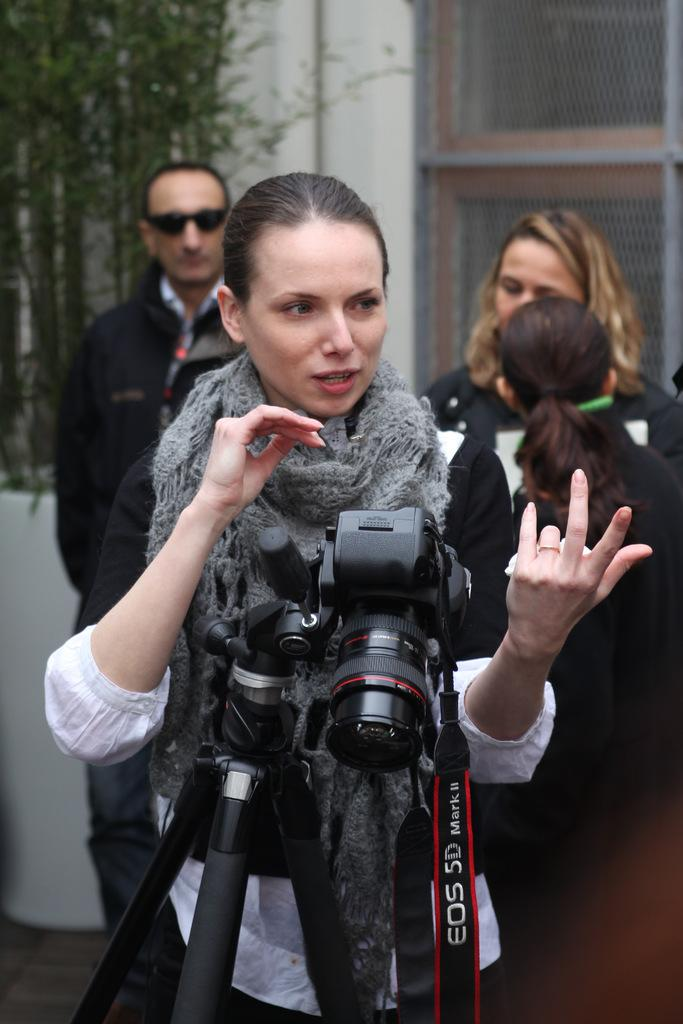Who or what can be seen in the image? There are people in the image. What object is used for capturing images in the scene? There is a camera placed on a stand in the image. What type of vegetation is on the left side of the image? There is a tree on the left side of the image. What type of structure is visible in the background of the image? There is a building in the background of the image. What type of beetle can be seen crawling on the camera in the image? There is no beetle present on the camera in the image. How many crows are perched on the tree in the image? There are no crows visible in the image; only a tree is present on the left side. 